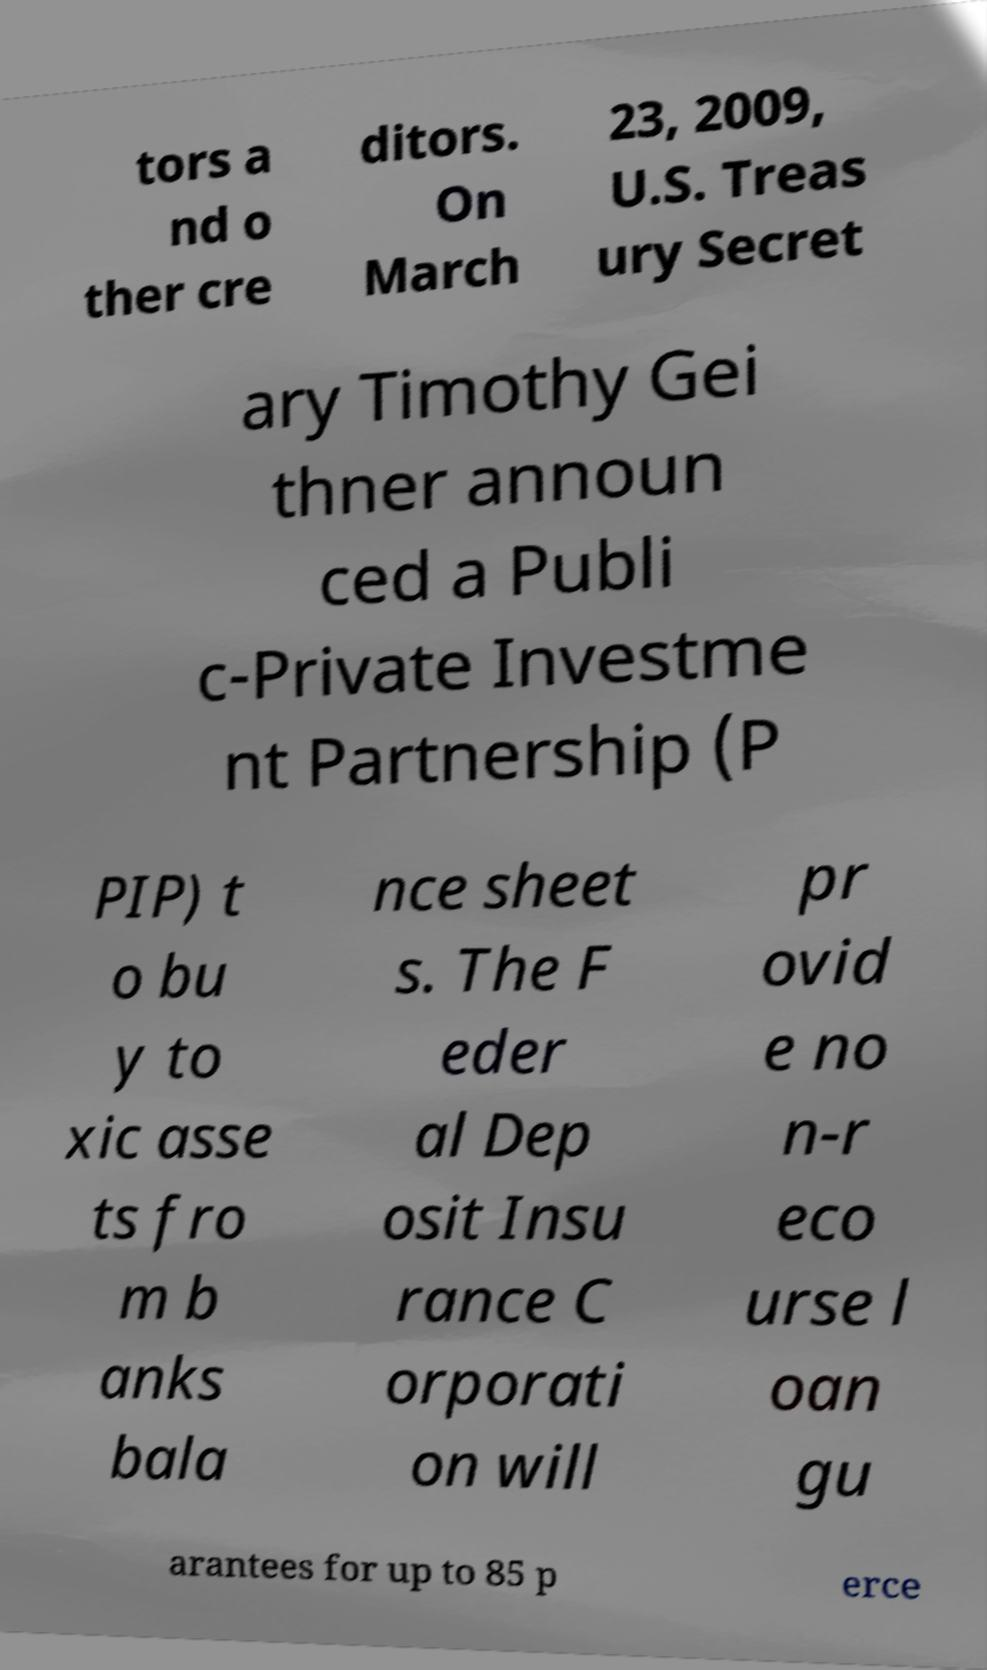I need the written content from this picture converted into text. Can you do that? tors a nd o ther cre ditors. On March 23, 2009, U.S. Treas ury Secret ary Timothy Gei thner announ ced a Publi c-Private Investme nt Partnership (P PIP) t o bu y to xic asse ts fro m b anks bala nce sheet s. The F eder al Dep osit Insu rance C orporati on will pr ovid e no n-r eco urse l oan gu arantees for up to 85 p erce 